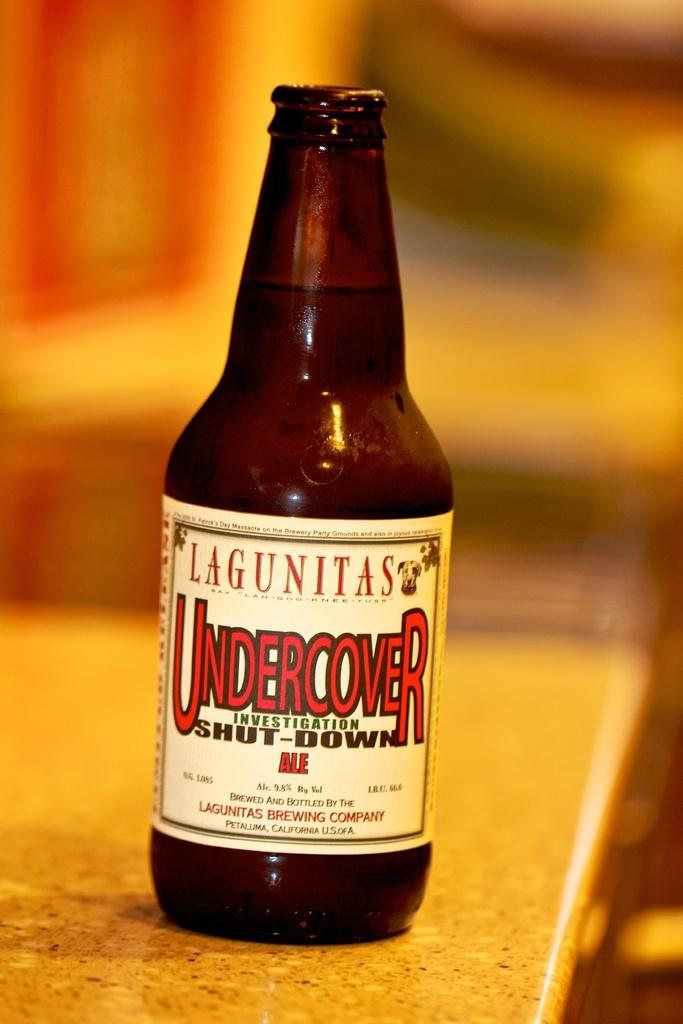<image>
Relay a brief, clear account of the picture shown. A bottle, labelled Lagunitas Undercover, is on a counter. 